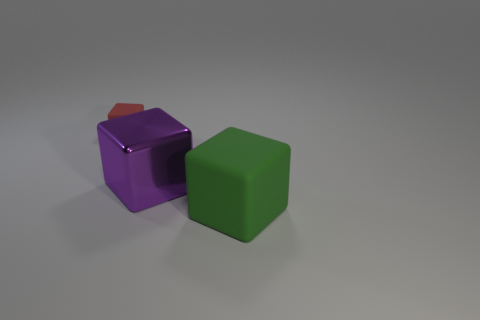Add 2 tiny red matte blocks. How many objects exist? 5 Add 1 large matte objects. How many large matte objects exist? 2 Subtract 0 yellow cubes. How many objects are left? 3 Subtract all tiny rubber things. Subtract all large purple metallic objects. How many objects are left? 1 Add 2 large blocks. How many large blocks are left? 4 